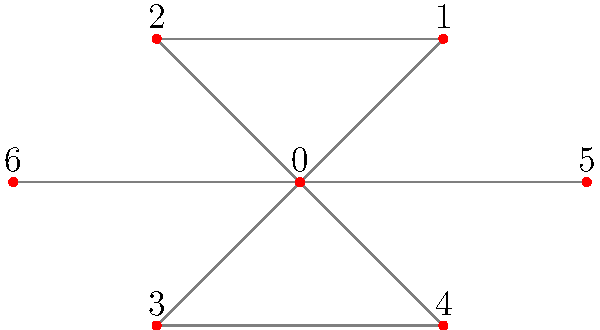As a Volunteers fan who links emotions to game outcomes, you've created a network where nodes represent different emotions and edges connect emotions often felt together during games. The diagram shows this network. What is the degree of the node labeled 0, which represents your primary emotion after a close victory against Florida? To determine the degree of node 0, we need to follow these steps:

1. Understand what degree means in a network:
   The degree of a node is the number of edges connected to it.

2. Identify node 0 in the network:
   Node 0 is at the center of the diagram.

3. Count the number of edges connected to node 0:
   - Edge connecting 0 to 1 (excitement)
   - Edge connecting 0 to 2 (pride)
   - Edge connecting 0 to 3 (relief)
   - Edge connecting 0 to 4 (anxiety)
   - Edge connecting 0 to 5 (joy)
   - Edge connecting 0 to 6 (satisfaction)

4. Sum up the total number of edges:
   There are 6 edges connected to node 0.

Therefore, the degree of node 0 is 6, representing the complex mix of emotions you typically experience after a close victory against a rival like Florida.
Answer: 6 